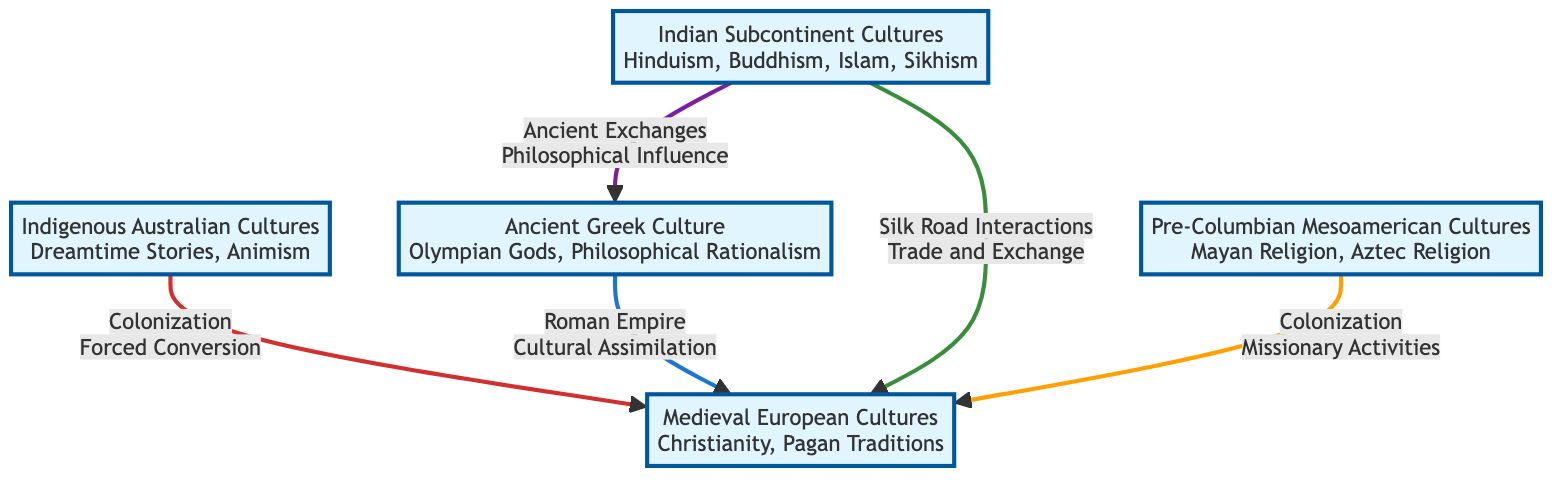What are the dominant beliefs of Indigenous Australian Cultures? The diagram indicates the dominant beliefs of Indigenous Australian Cultures as "Dreamtime Stories" and "Animism" listed under the node for Cultural Group 1.
Answer: Dreamtime Stories, Animism How many cultural groups are represented in this diagram? Counting the nodes in the diagram, there are five cultural groups displayed: Indigenous Australian Cultures, Ancient Greek Culture, Medieval European Cultures, Indian Subcontinent Cultures, and Pre-Columbian Mesoamerican Cultures.
Answer: 5 What is the relationship between Ancient Greek Culture and Medieval European Cultures? The diagram shows that the relationship between Ancient Greek Culture and Medieval European Cultures is defined by the link labeled "Roman Empire" with a transmission type of "Cultural Assimilation."
Answer: Roman Empire, Cultural Assimilation Which cultural group influenced Medieval European Cultures through the Silk Road? The link from Indian Subcontinent Cultures to Medieval European Cultures indicates that Indian Subcontinent Cultures influenced Medieval European Cultures through "Silk Road Interactions" and the transmission type noted as "Trade and Exchange."
Answer: Indian Subcontinent Cultures What type of transmission occurred from Pre-Columbian Mesoamerican Cultures to Medieval European Cultures? The diagram illustrates that the transmission from Pre-Columbian Mesoamerican Cultures to Medieval European Cultures occurred through "Colonization," specifically noted as "Missionary Activities."
Answer: Missionary Activities Which cultural groups are connected to Medieval European Cultures? The diagram reveals that Medieval European Cultures is connected to four cultural groups: Indigenous Australian Cultures, Ancient Greek Culture, Indian Subcontinent Cultures, and Pre-Columbian Mesoamerican Cultures.
Answer: 4 What type of influence connects Indian Subcontinent Cultures with Ancient Greek Culture? The diagram indicates that the influence connecting Indian Subcontinent Cultures with Ancient Greek Culture is described as "Ancient Exchanges" with the transmission type being "Philosophical Influence."
Answer: Ancient Exchanges, Philosophical Influence Which two cultural groups have a direct link due to Roman Empire influences? The diagram shows a direct link due to Roman Empire influences between Ancient Greek Culture and Medieval European Cultures.
Answer: Ancient Greek Culture, Medieval European Cultures What is the geographical region of Indigenous Australian Cultures? The diagram specifies that the geographical region of Indigenous Australian Cultures is "Australia."
Answer: Australia 